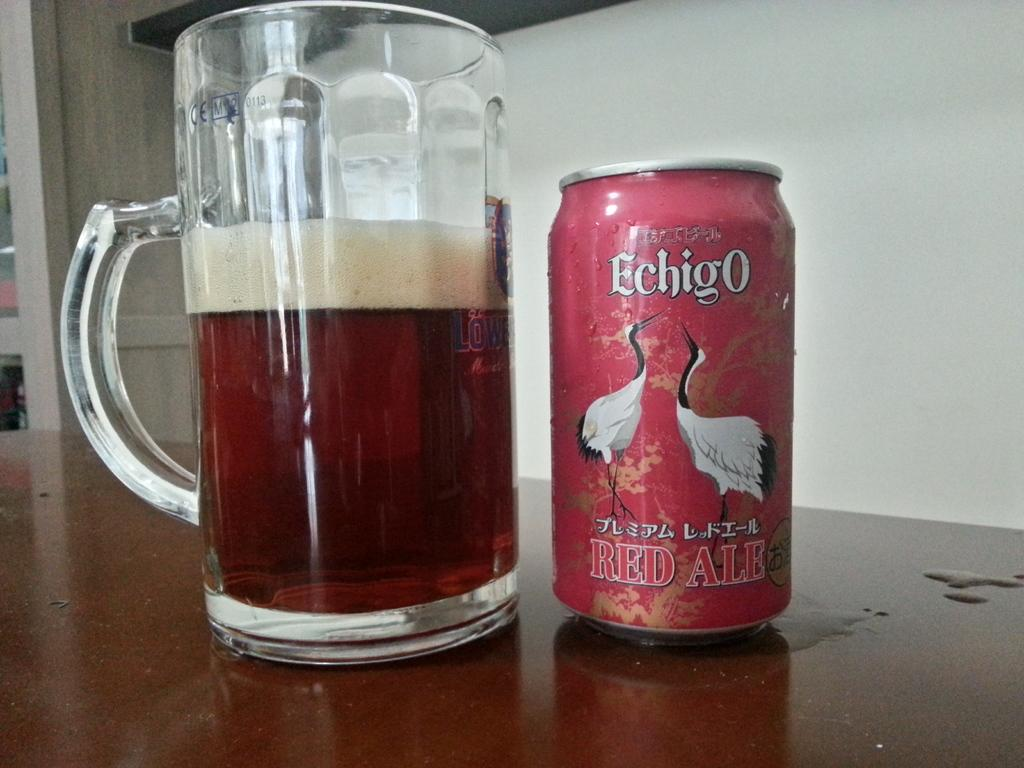<image>
Offer a succinct explanation of the picture presented. A can of Echigo Red Ale sits next to a half full mug. 